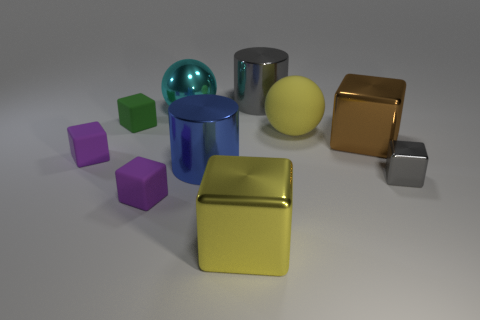What is the size of the gray block that is the same material as the brown object?
Provide a short and direct response. Small. There is a block that is to the left of the yellow metallic cube and right of the small green block; what material is it?
Ensure brevity in your answer.  Rubber. How many green objects have the same size as the yellow matte thing?
Your answer should be compact. 0. There is another large object that is the same shape as the large blue thing; what is it made of?
Your answer should be compact. Metal. How many objects are either metal blocks that are behind the yellow metallic thing or small blocks that are behind the large brown object?
Give a very brief answer. 3. Is the shape of the cyan thing the same as the large gray thing behind the large blue shiny cylinder?
Your response must be concise. No. There is a large yellow object behind the matte object to the left of the tiny object that is behind the yellow sphere; what shape is it?
Give a very brief answer. Sphere. What number of other things are there of the same material as the blue object
Your response must be concise. 5. How many objects are objects that are behind the yellow sphere or big yellow shiny things?
Your response must be concise. 4. What is the shape of the purple thing to the right of the tiny thing that is behind the brown shiny thing?
Your response must be concise. Cube. 